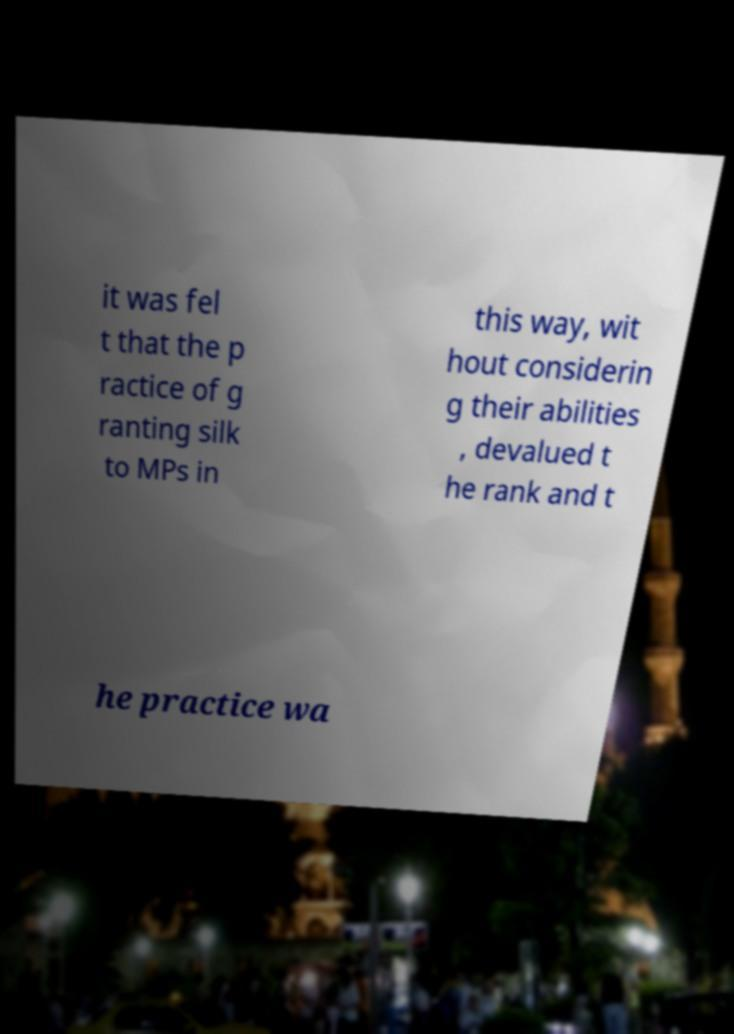For documentation purposes, I need the text within this image transcribed. Could you provide that? it was fel t that the p ractice of g ranting silk to MPs in this way, wit hout considerin g their abilities , devalued t he rank and t he practice wa 